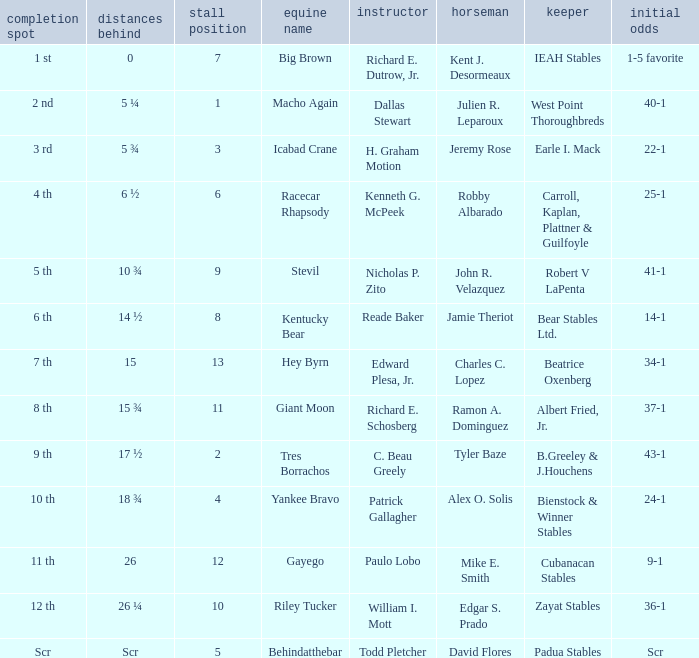Who was the jockey that had post time odds of 34-1? Charles C. Lopez. 